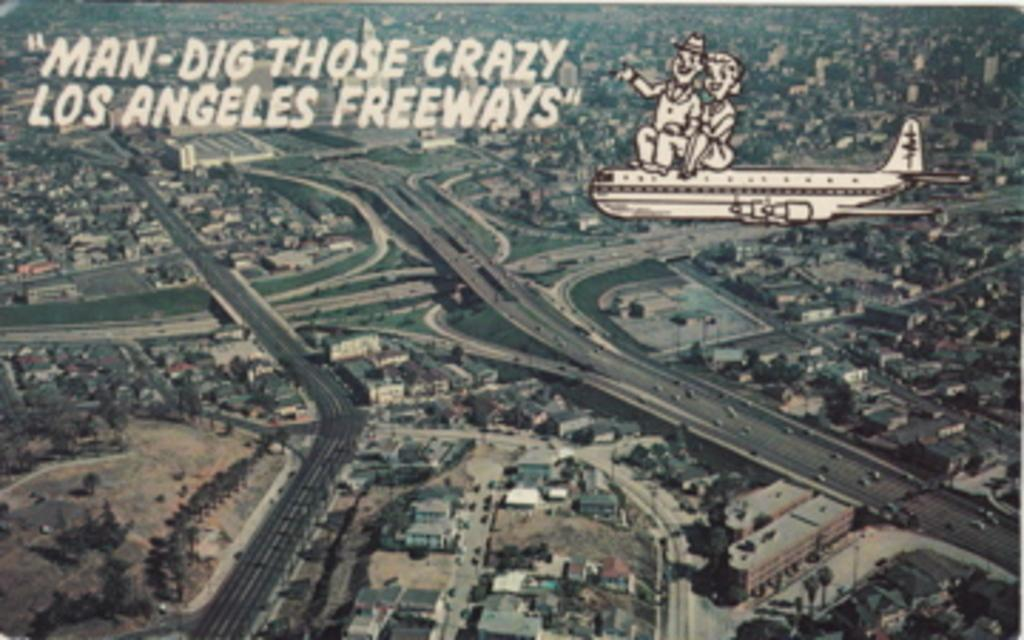What type of view is shown in the image? The image is an aerial view of a city. What can be seen on the ground in the image? There are roads, houses, buildings, trees, and grass surfaces visible in the image. What text is written on the image? The text "man dig those crazy Los angeles" is written on the image. What type of print can be seen on the throat of the person in the image? There is no person present in the image, and therefore no throat or print to observe. What type of school can be seen in the image? There is no school visible in the image; it is an aerial view of a city with various elements such as roads, houses, buildings, trees, and grass surfaces. 